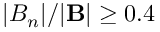Convert formula to latex. <formula><loc_0><loc_0><loc_500><loc_500>| B _ { n } | / | B | \geq 0 . 4</formula> 